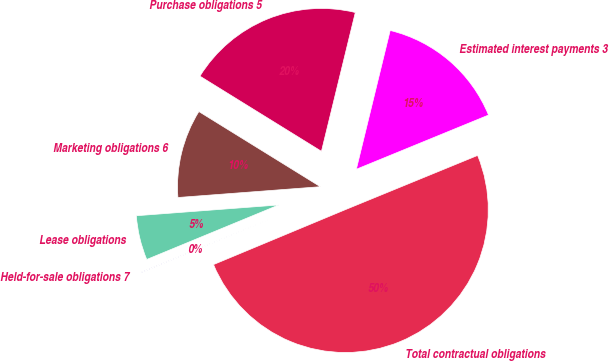Convert chart. <chart><loc_0><loc_0><loc_500><loc_500><pie_chart><fcel>Estimated interest payments 3<fcel>Purchase obligations 5<fcel>Marketing obligations 6<fcel>Lease obligations<fcel>Held-for-sale obligations 7<fcel>Total contractual obligations<nl><fcel>15.0%<fcel>19.99%<fcel>10.02%<fcel>5.03%<fcel>0.05%<fcel>49.91%<nl></chart> 